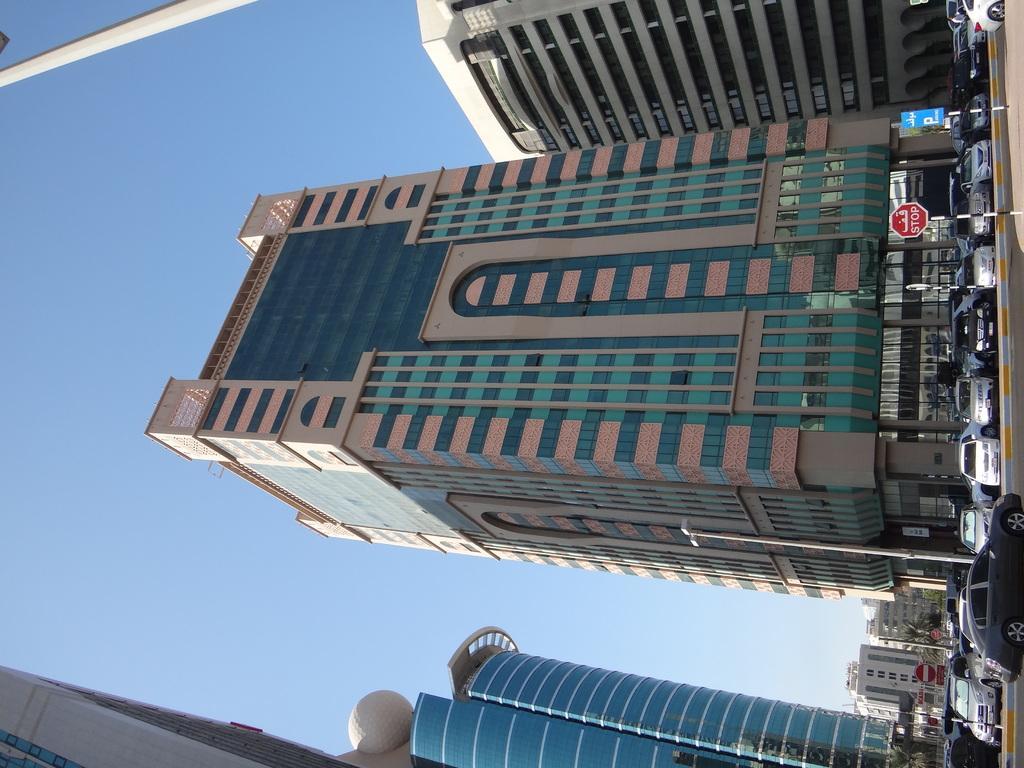How would you summarize this image in a sentence or two? In this picture I can see there are few cars parked at the left of the road and there is a car moving on the road and there are few precaution boards and street lights and in the backdrop there are buildings and they have glass windows. The sky is clear. 